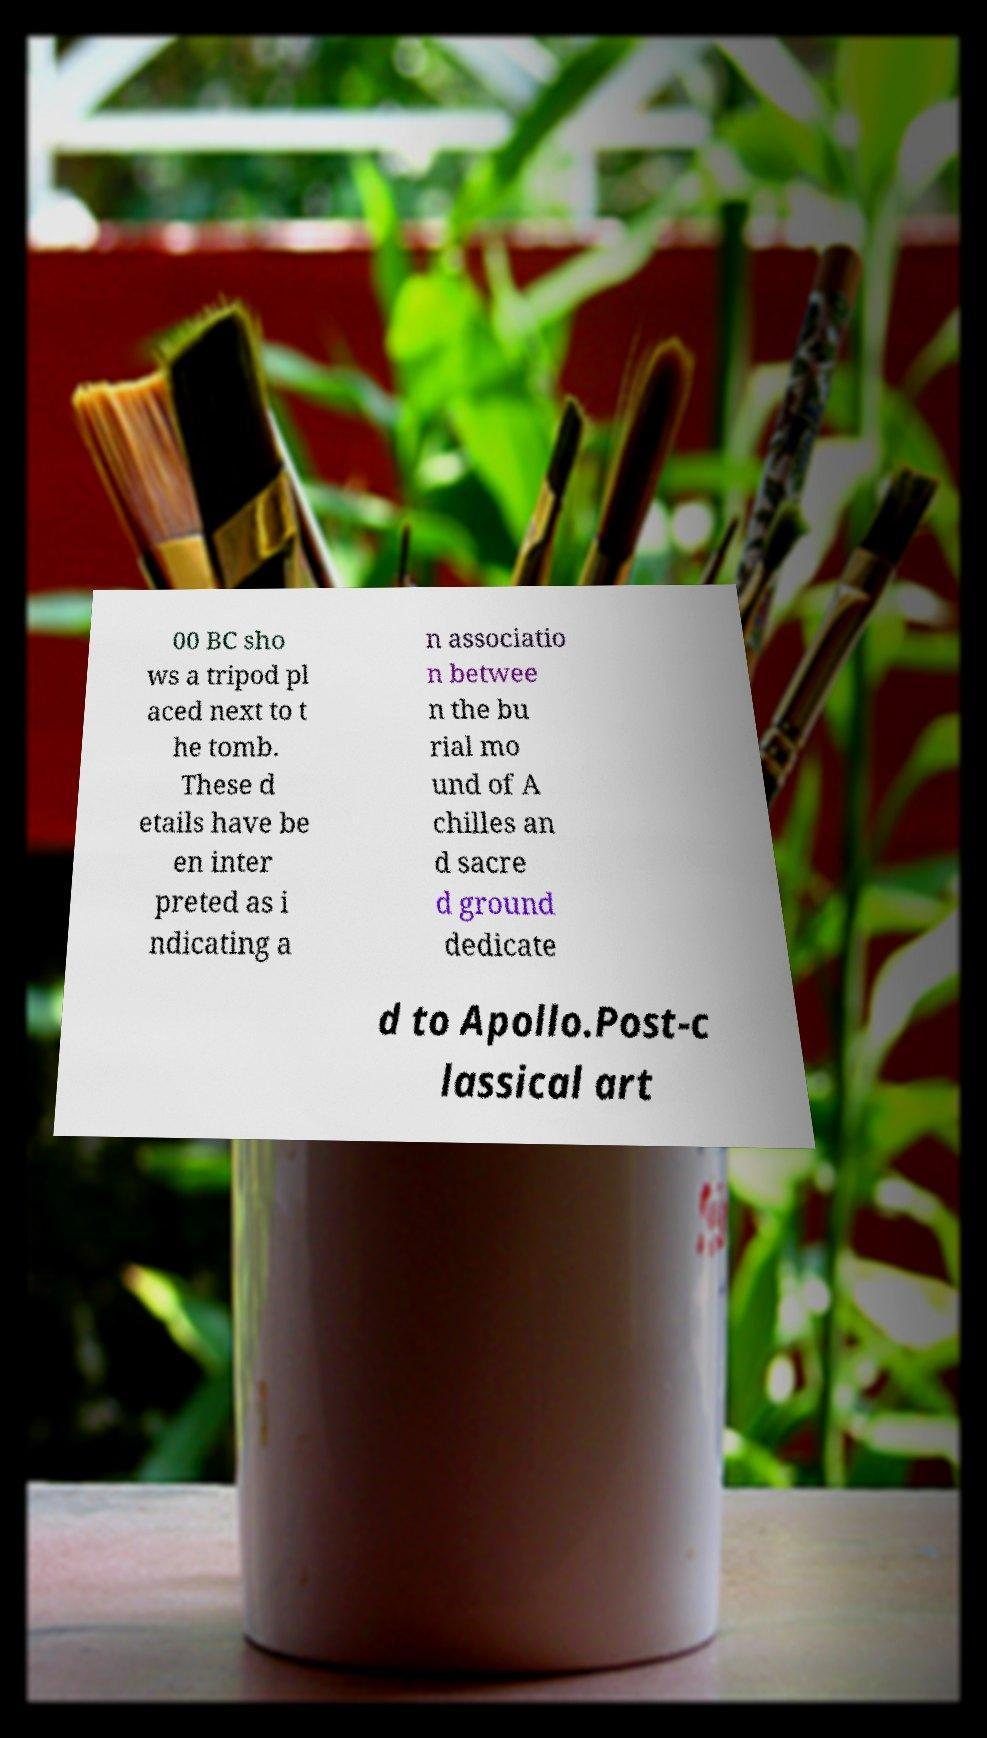Can you read and provide the text displayed in the image?This photo seems to have some interesting text. Can you extract and type it out for me? 00 BC sho ws a tripod pl aced next to t he tomb. These d etails have be en inter preted as i ndicating a n associatio n betwee n the bu rial mo und of A chilles an d sacre d ground dedicate d to Apollo.Post-c lassical art 